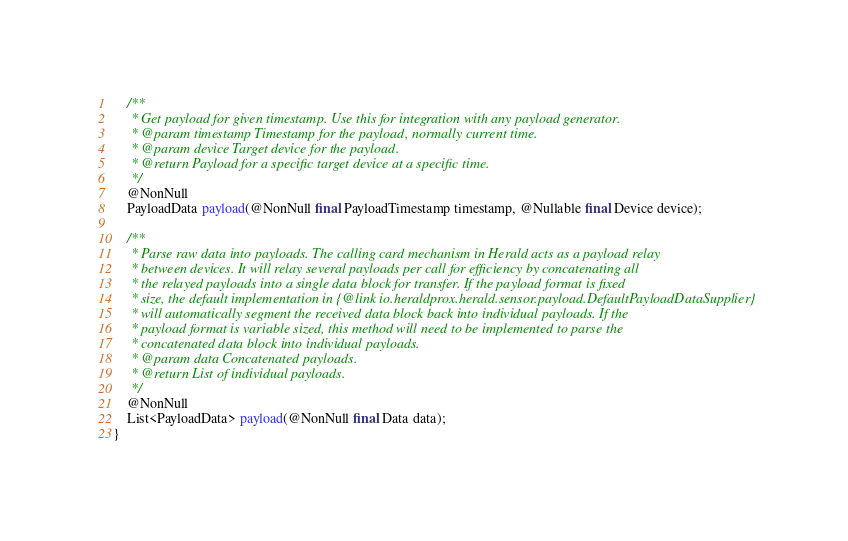Convert code to text. <code><loc_0><loc_0><loc_500><loc_500><_Java_>    /**
     * Get payload for given timestamp. Use this for integration with any payload generator.
     * @param timestamp Timestamp for the payload, normally current time.
     * @param device Target device for the payload.
     * @return Payload for a specific target device at a specific time.
     */
    @NonNull
    PayloadData payload(@NonNull final PayloadTimestamp timestamp, @Nullable final Device device);

    /**
     * Parse raw data into payloads. The calling card mechanism in Herald acts as a payload relay
     * between devices. It will relay several payloads per call for efficiency by concatenating all
     * the relayed payloads into a single data block for transfer. If the payload format is fixed
     * size, the default implementation in {@link io.heraldprox.herald.sensor.payload.DefaultPayloadDataSupplier}
     * will automatically segment the received data block back into individual payloads. If the
     * payload format is variable sized, this method will need to be implemented to parse the
     * concatenated data block into individual payloads.
     * @param data Concatenated payloads.
     * @return List of individual payloads.
     */
    @NonNull
    List<PayloadData> payload(@NonNull final Data data);
}
</code> 